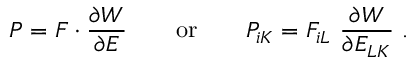Convert formula to latex. <formula><loc_0><loc_0><loc_500><loc_500>{ P } = { F } \cdot { \frac { \partial W } { \partial { E } } } \quad { o r } \quad P _ { i K } = F _ { i L } { \frac { \partial W } { \partial E _ { L K } } } .</formula> 